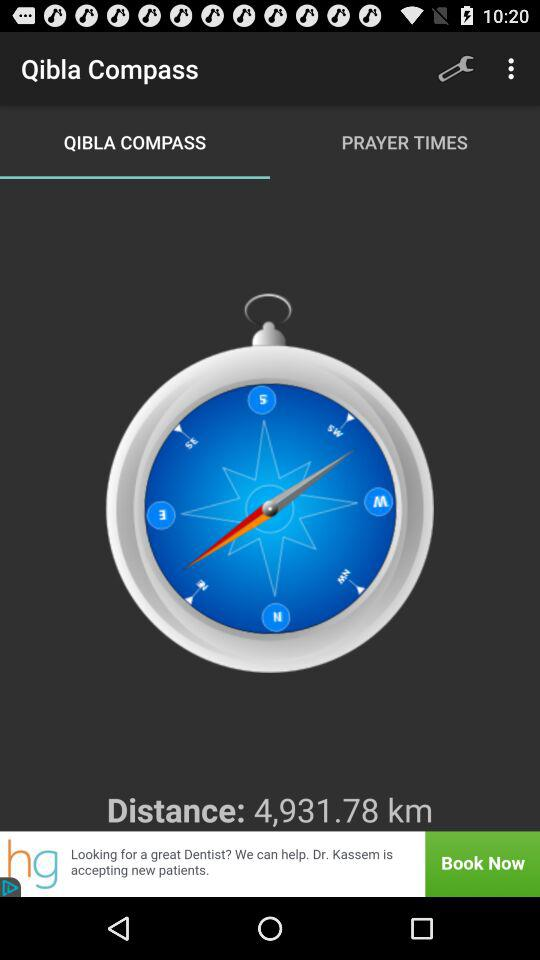When is prayer time?
When the provided information is insufficient, respond with <no answer>. <no answer> 